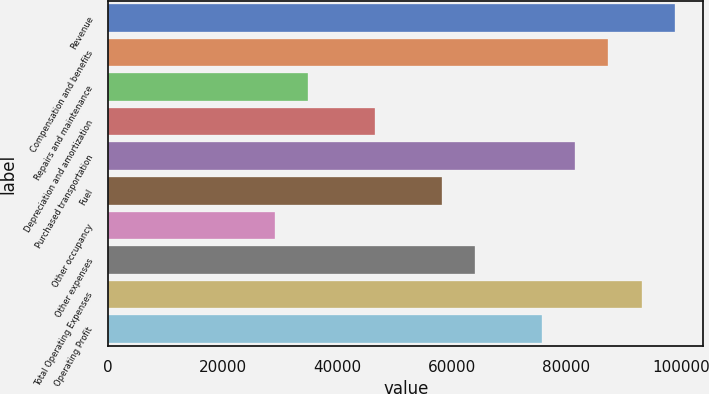Convert chart. <chart><loc_0><loc_0><loc_500><loc_500><bar_chart><fcel>Revenue<fcel>Compensation and benefits<fcel>Repairs and maintenance<fcel>Depreciation and amortization<fcel>Purchased transportation<fcel>Fuel<fcel>Other occupancy<fcel>Other expenses<fcel>Total Operating Expenses<fcel>Operating Profit<nl><fcel>98992.1<fcel>87346.3<fcel>34940.5<fcel>46586.2<fcel>81523.5<fcel>58232<fcel>29117.6<fcel>64054.8<fcel>93169.2<fcel>75700.6<nl></chart> 